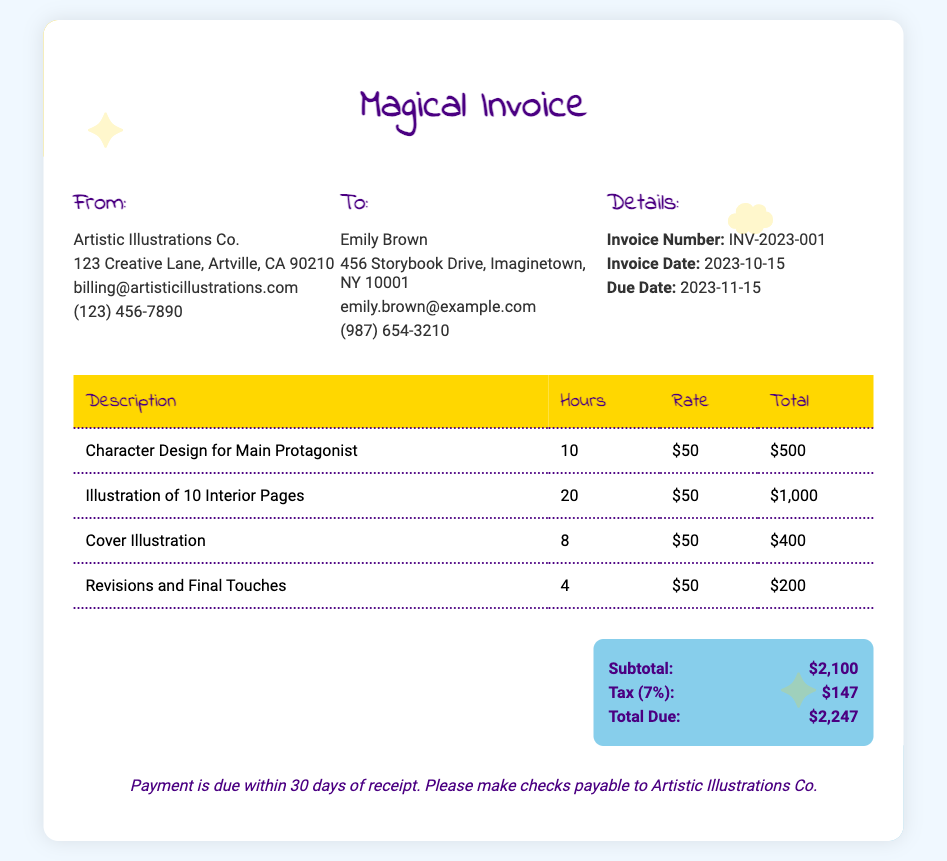What is the invoice number? The invoice number is a unique identifier for the invoice listed in the document.
Answer: INV-2023-001 When is the due date? The due date is the date by which payment must be made as specified in the document.
Answer: 2023-11-15 How many hours were spent on character design? The hours spent on character design can be found in the detailed section of the invoice, specifically stating the time allocated.
Answer: 10 What is the total amount due? The total amount due is the final amount that needs to be paid and is calculated based on the subtotal and tax.
Answer: $2,247 What is the tax percentage applied? The tax percentage is provided in the summary section as part of the calculation of the total due.
Answer: 7% Who is the recipient of the invoice? The recipient's name is given in the "To" section of the document.
Answer: Emily Brown What was the rate per hour for the services? The rate per hour is a fixed amount applied to the services rendered, mentioned throughout the document.
Answer: $50 How many revisions were included? The number of revisions performed is found in the detailed breakdown of services on the invoice.
Answer: 4 